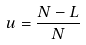Convert formula to latex. <formula><loc_0><loc_0><loc_500><loc_500>u = \frac { N - L } { N }</formula> 